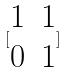Convert formula to latex. <formula><loc_0><loc_0><loc_500><loc_500>[ \begin{matrix} 1 & 1 \\ 0 & 1 \end{matrix} ]</formula> 